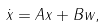<formula> <loc_0><loc_0><loc_500><loc_500>\dot { x } = A x + B w ,</formula> 